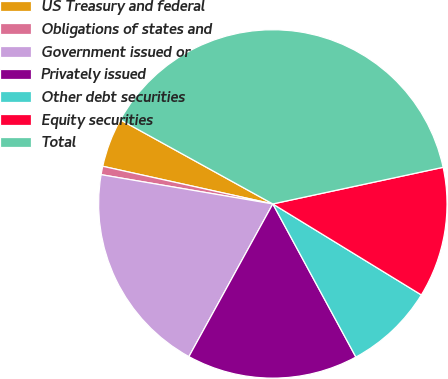Convert chart. <chart><loc_0><loc_0><loc_500><loc_500><pie_chart><fcel>US Treasury and federal<fcel>Obligations of states and<fcel>Government issued or<fcel>Privately issued<fcel>Other debt securities<fcel>Equity securities<fcel>Total<nl><fcel>4.56%<fcel>0.78%<fcel>19.69%<fcel>15.91%<fcel>8.34%<fcel>12.12%<fcel>38.6%<nl></chart> 